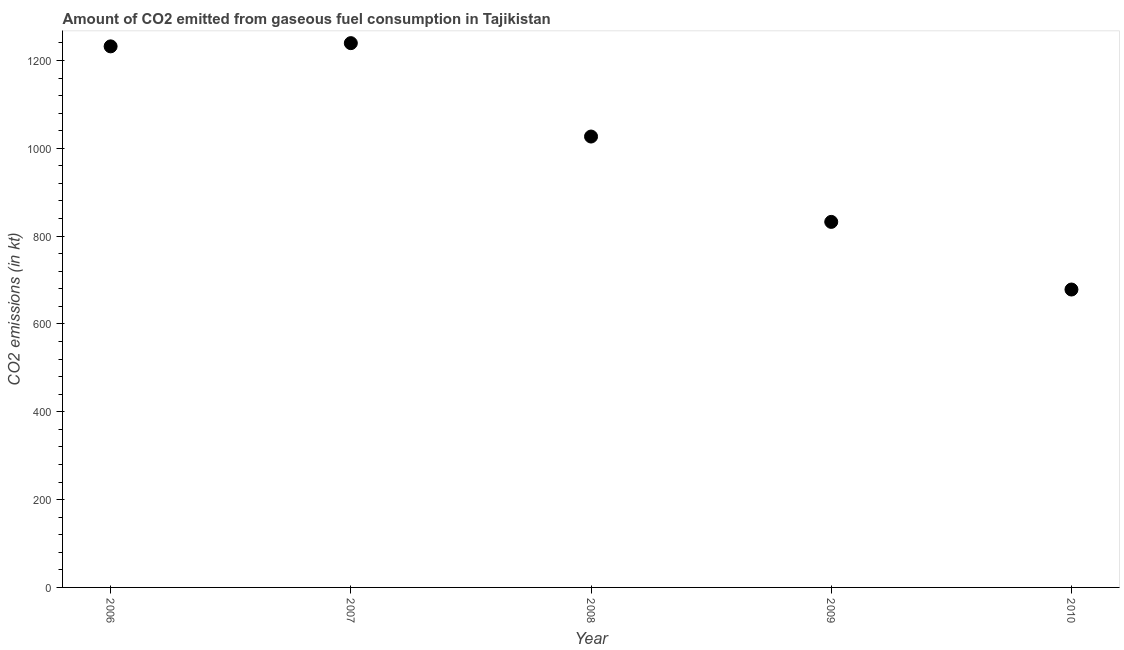What is the co2 emissions from gaseous fuel consumption in 2008?
Your answer should be compact. 1026.76. Across all years, what is the maximum co2 emissions from gaseous fuel consumption?
Offer a very short reply. 1239.45. Across all years, what is the minimum co2 emissions from gaseous fuel consumption?
Make the answer very short. 678.39. In which year was the co2 emissions from gaseous fuel consumption maximum?
Give a very brief answer. 2007. What is the sum of the co2 emissions from gaseous fuel consumption?
Give a very brief answer. 5009.12. What is the difference between the co2 emissions from gaseous fuel consumption in 2008 and 2010?
Your answer should be compact. 348.37. What is the average co2 emissions from gaseous fuel consumption per year?
Your answer should be very brief. 1001.82. What is the median co2 emissions from gaseous fuel consumption?
Offer a very short reply. 1026.76. What is the ratio of the co2 emissions from gaseous fuel consumption in 2009 to that in 2010?
Make the answer very short. 1.23. Is the co2 emissions from gaseous fuel consumption in 2006 less than that in 2008?
Ensure brevity in your answer.  No. What is the difference between the highest and the second highest co2 emissions from gaseous fuel consumption?
Your response must be concise. 7.33. What is the difference between the highest and the lowest co2 emissions from gaseous fuel consumption?
Give a very brief answer. 561.05. How many dotlines are there?
Offer a very short reply. 1. Does the graph contain any zero values?
Your response must be concise. No. What is the title of the graph?
Offer a very short reply. Amount of CO2 emitted from gaseous fuel consumption in Tajikistan. What is the label or title of the X-axis?
Provide a short and direct response. Year. What is the label or title of the Y-axis?
Provide a short and direct response. CO2 emissions (in kt). What is the CO2 emissions (in kt) in 2006?
Your response must be concise. 1232.11. What is the CO2 emissions (in kt) in 2007?
Provide a short and direct response. 1239.45. What is the CO2 emissions (in kt) in 2008?
Provide a short and direct response. 1026.76. What is the CO2 emissions (in kt) in 2009?
Keep it short and to the point. 832.41. What is the CO2 emissions (in kt) in 2010?
Offer a very short reply. 678.39. What is the difference between the CO2 emissions (in kt) in 2006 and 2007?
Make the answer very short. -7.33. What is the difference between the CO2 emissions (in kt) in 2006 and 2008?
Your answer should be very brief. 205.35. What is the difference between the CO2 emissions (in kt) in 2006 and 2009?
Your response must be concise. 399.7. What is the difference between the CO2 emissions (in kt) in 2006 and 2010?
Offer a very short reply. 553.72. What is the difference between the CO2 emissions (in kt) in 2007 and 2008?
Make the answer very short. 212.69. What is the difference between the CO2 emissions (in kt) in 2007 and 2009?
Keep it short and to the point. 407.04. What is the difference between the CO2 emissions (in kt) in 2007 and 2010?
Offer a very short reply. 561.05. What is the difference between the CO2 emissions (in kt) in 2008 and 2009?
Give a very brief answer. 194.35. What is the difference between the CO2 emissions (in kt) in 2008 and 2010?
Your answer should be very brief. 348.37. What is the difference between the CO2 emissions (in kt) in 2009 and 2010?
Offer a terse response. 154.01. What is the ratio of the CO2 emissions (in kt) in 2006 to that in 2008?
Your answer should be compact. 1.2. What is the ratio of the CO2 emissions (in kt) in 2006 to that in 2009?
Offer a very short reply. 1.48. What is the ratio of the CO2 emissions (in kt) in 2006 to that in 2010?
Ensure brevity in your answer.  1.82. What is the ratio of the CO2 emissions (in kt) in 2007 to that in 2008?
Offer a terse response. 1.21. What is the ratio of the CO2 emissions (in kt) in 2007 to that in 2009?
Provide a short and direct response. 1.49. What is the ratio of the CO2 emissions (in kt) in 2007 to that in 2010?
Make the answer very short. 1.83. What is the ratio of the CO2 emissions (in kt) in 2008 to that in 2009?
Make the answer very short. 1.23. What is the ratio of the CO2 emissions (in kt) in 2008 to that in 2010?
Your answer should be compact. 1.51. What is the ratio of the CO2 emissions (in kt) in 2009 to that in 2010?
Your answer should be compact. 1.23. 